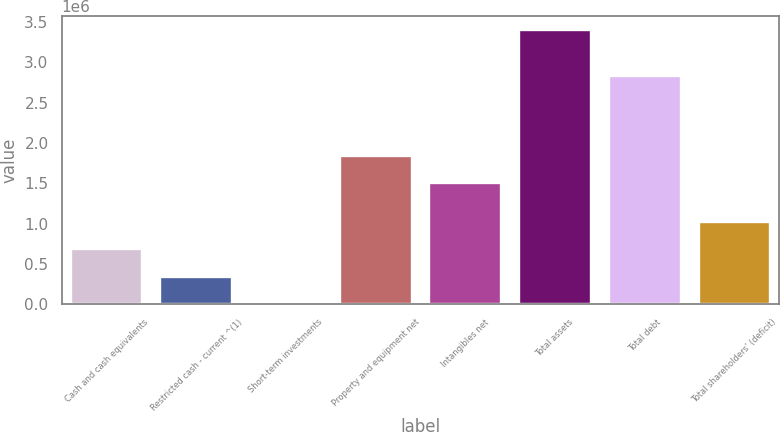<chart> <loc_0><loc_0><loc_500><loc_500><bar_chart><fcel>Cash and cash equivalents<fcel>Restricted cash - current ^(1)<fcel>Short-term investments<fcel>Property and equipment net<fcel>Intangibles net<fcel>Total assets<fcel>Total debt<fcel>Total shareholders' (deficit)<nl><fcel>683248<fcel>343632<fcel>4016<fcel>1.83963e+06<fcel>1.50001e+06<fcel>3.40018e+06<fcel>2.82745e+06<fcel>1.02286e+06<nl></chart> 